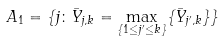Convert formula to latex. <formula><loc_0><loc_0><loc_500><loc_500>A _ { 1 } = \{ j \colon \bar { Y } _ { j , k } = \max _ { \{ 1 \leq j ^ { \prime } \leq k \} } \{ \bar { Y } _ { j ^ { \prime } , k } \} \}</formula> 